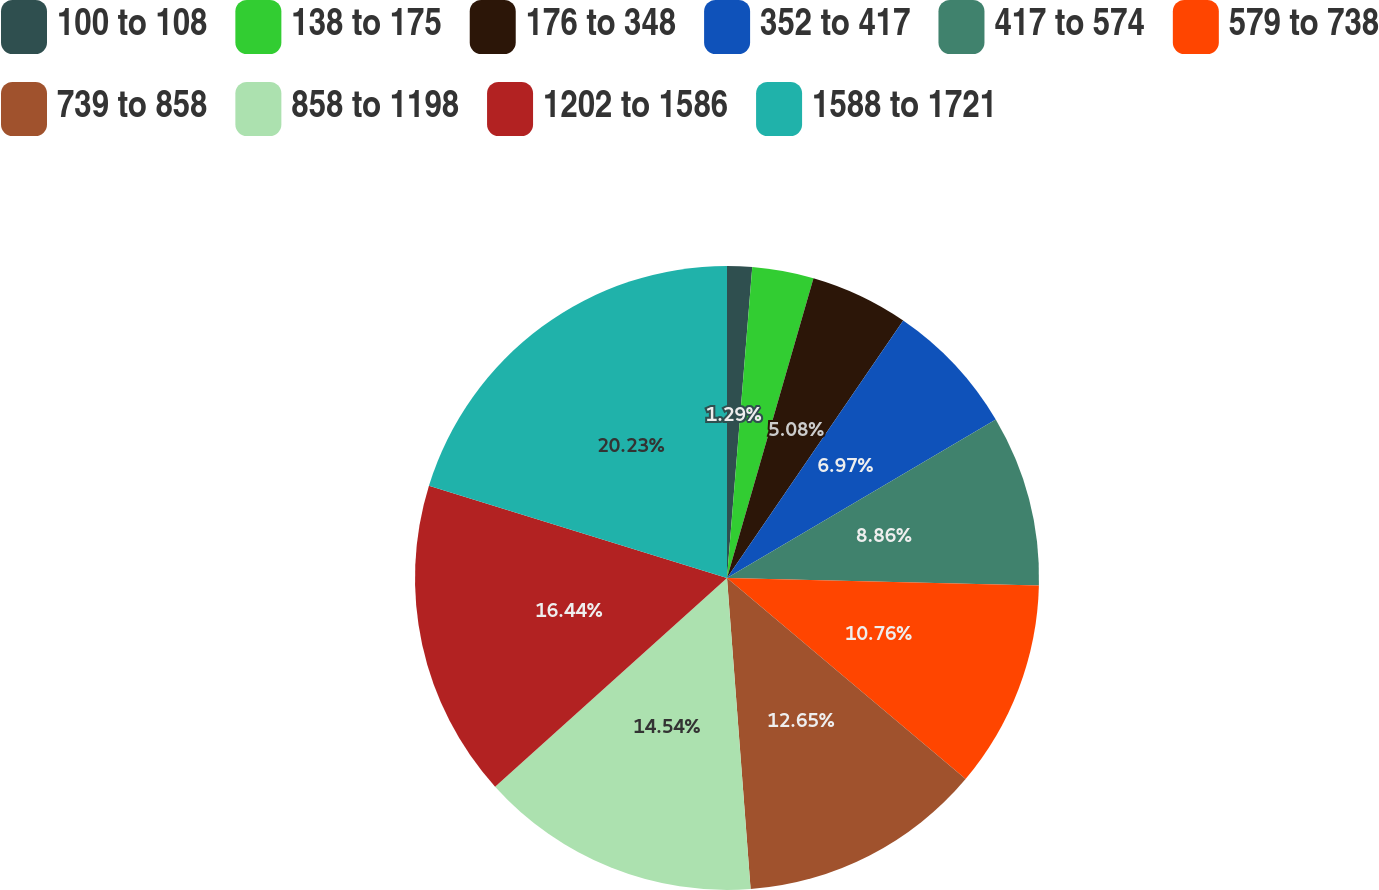Convert chart to OTSL. <chart><loc_0><loc_0><loc_500><loc_500><pie_chart><fcel>100 to 108<fcel>138 to 175<fcel>176 to 348<fcel>352 to 417<fcel>417 to 574<fcel>579 to 738<fcel>739 to 858<fcel>858 to 1198<fcel>1202 to 1586<fcel>1588 to 1721<nl><fcel>1.29%<fcel>3.18%<fcel>5.08%<fcel>6.97%<fcel>8.86%<fcel>10.76%<fcel>12.65%<fcel>14.54%<fcel>16.44%<fcel>20.22%<nl></chart> 